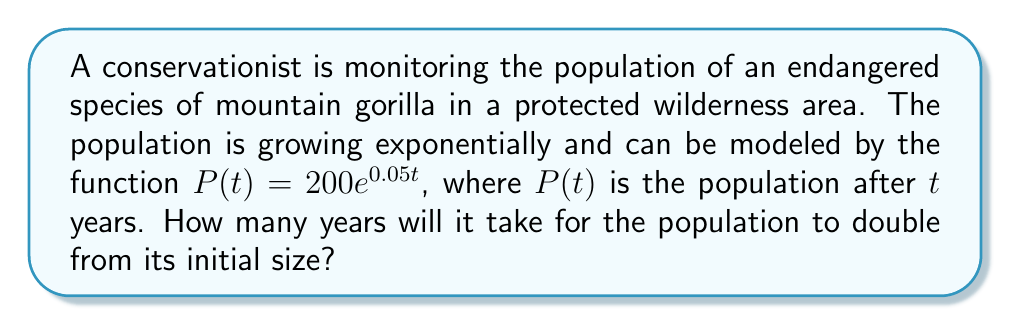Can you solve this math problem? To solve this problem, we'll use the properties of logarithms and exponential functions:

1. We know that the initial population is 200 (when $t=0$).
2. We want to find $t$ when the population is 400 (double the initial population).

Let's set up the equation:

$$400 = 200e^{0.05t}$$

3. Divide both sides by 200:

$$2 = e^{0.05t}$$

4. Take the natural logarithm of both sides:

$$\ln(2) = \ln(e^{0.05t})$$

5. Using the logarithm property $\ln(e^x) = x$, we get:

$$\ln(2) = 0.05t$$

6. Solve for $t$:

$$t = \frac{\ln(2)}{0.05}$$

7. Calculate the result:

$$t = \frac{0.693147...}{0.05} \approx 13.86$$

Therefore, it will take approximately 13.86 years for the population to double.
Answer: $13.86$ years 